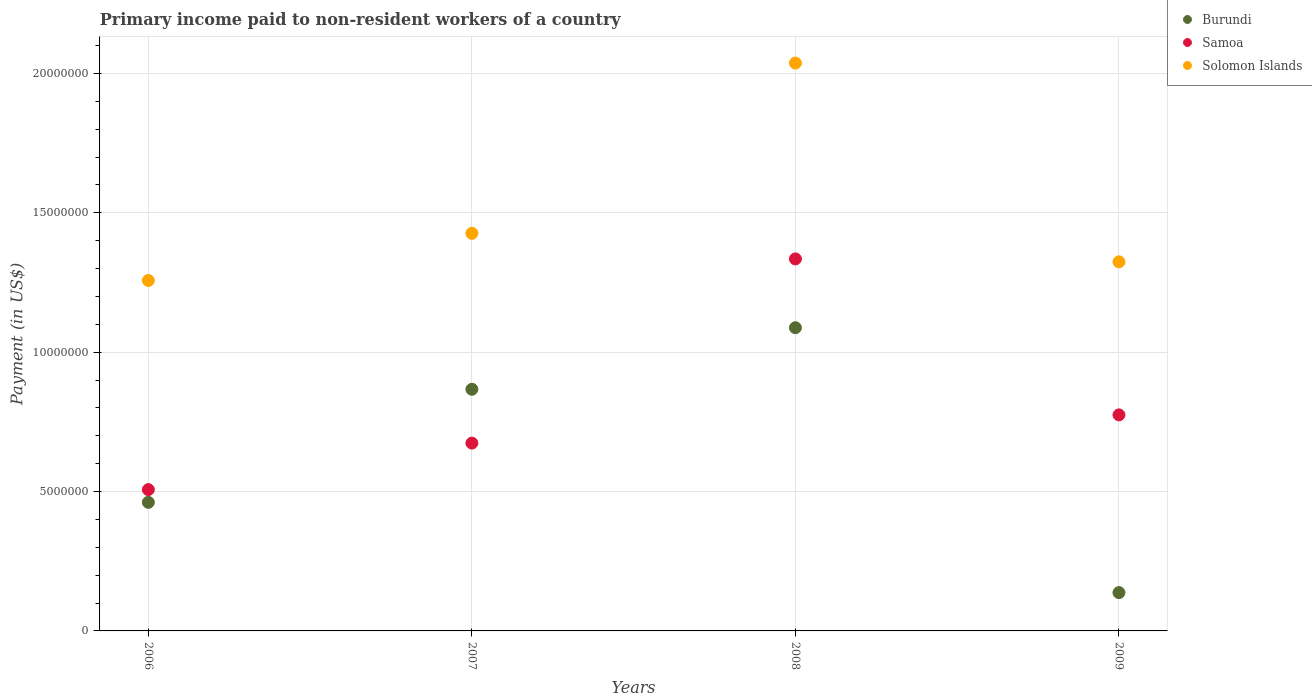How many different coloured dotlines are there?
Give a very brief answer. 3. What is the amount paid to workers in Samoa in 2009?
Make the answer very short. 7.75e+06. Across all years, what is the maximum amount paid to workers in Samoa?
Your answer should be very brief. 1.33e+07. Across all years, what is the minimum amount paid to workers in Solomon Islands?
Your answer should be compact. 1.26e+07. In which year was the amount paid to workers in Solomon Islands minimum?
Keep it short and to the point. 2006. What is the total amount paid to workers in Samoa in the graph?
Make the answer very short. 3.29e+07. What is the difference between the amount paid to workers in Burundi in 2006 and that in 2008?
Give a very brief answer. -6.27e+06. What is the difference between the amount paid to workers in Burundi in 2006 and the amount paid to workers in Samoa in 2007?
Your answer should be compact. -2.13e+06. What is the average amount paid to workers in Burundi per year?
Make the answer very short. 6.38e+06. In the year 2008, what is the difference between the amount paid to workers in Solomon Islands and amount paid to workers in Burundi?
Offer a very short reply. 9.50e+06. In how many years, is the amount paid to workers in Solomon Islands greater than 15000000 US$?
Offer a terse response. 1. What is the ratio of the amount paid to workers in Solomon Islands in 2006 to that in 2007?
Provide a succinct answer. 0.88. Is the difference between the amount paid to workers in Solomon Islands in 2007 and 2009 greater than the difference between the amount paid to workers in Burundi in 2007 and 2009?
Ensure brevity in your answer.  No. What is the difference between the highest and the second highest amount paid to workers in Burundi?
Offer a terse response. 2.21e+06. What is the difference between the highest and the lowest amount paid to workers in Solomon Islands?
Keep it short and to the point. 7.80e+06. In how many years, is the amount paid to workers in Burundi greater than the average amount paid to workers in Burundi taken over all years?
Make the answer very short. 2. Is the amount paid to workers in Samoa strictly greater than the amount paid to workers in Burundi over the years?
Keep it short and to the point. No. Is the amount paid to workers in Burundi strictly less than the amount paid to workers in Samoa over the years?
Provide a short and direct response. No. How many dotlines are there?
Make the answer very short. 3. How many years are there in the graph?
Your answer should be very brief. 4. What is the difference between two consecutive major ticks on the Y-axis?
Offer a terse response. 5.00e+06. Are the values on the major ticks of Y-axis written in scientific E-notation?
Give a very brief answer. No. Does the graph contain any zero values?
Offer a terse response. No. Does the graph contain grids?
Offer a very short reply. Yes. Where does the legend appear in the graph?
Keep it short and to the point. Top right. How many legend labels are there?
Give a very brief answer. 3. What is the title of the graph?
Keep it short and to the point. Primary income paid to non-resident workers of a country. Does "New Zealand" appear as one of the legend labels in the graph?
Offer a terse response. No. What is the label or title of the Y-axis?
Keep it short and to the point. Payment (in US$). What is the Payment (in US$) of Burundi in 2006?
Keep it short and to the point. 4.61e+06. What is the Payment (in US$) of Samoa in 2006?
Your answer should be compact. 5.07e+06. What is the Payment (in US$) in Solomon Islands in 2006?
Your answer should be very brief. 1.26e+07. What is the Payment (in US$) of Burundi in 2007?
Make the answer very short. 8.67e+06. What is the Payment (in US$) of Samoa in 2007?
Your response must be concise. 6.74e+06. What is the Payment (in US$) in Solomon Islands in 2007?
Offer a very short reply. 1.43e+07. What is the Payment (in US$) of Burundi in 2008?
Your response must be concise. 1.09e+07. What is the Payment (in US$) of Samoa in 2008?
Give a very brief answer. 1.33e+07. What is the Payment (in US$) of Solomon Islands in 2008?
Your answer should be compact. 2.04e+07. What is the Payment (in US$) of Burundi in 2009?
Offer a very short reply. 1.38e+06. What is the Payment (in US$) in Samoa in 2009?
Provide a short and direct response. 7.75e+06. What is the Payment (in US$) of Solomon Islands in 2009?
Provide a succinct answer. 1.32e+07. Across all years, what is the maximum Payment (in US$) in Burundi?
Offer a terse response. 1.09e+07. Across all years, what is the maximum Payment (in US$) in Samoa?
Provide a succinct answer. 1.33e+07. Across all years, what is the maximum Payment (in US$) of Solomon Islands?
Ensure brevity in your answer.  2.04e+07. Across all years, what is the minimum Payment (in US$) of Burundi?
Offer a very short reply. 1.38e+06. Across all years, what is the minimum Payment (in US$) of Samoa?
Provide a short and direct response. 5.07e+06. Across all years, what is the minimum Payment (in US$) of Solomon Islands?
Provide a short and direct response. 1.26e+07. What is the total Payment (in US$) in Burundi in the graph?
Offer a very short reply. 2.55e+07. What is the total Payment (in US$) of Samoa in the graph?
Your answer should be very brief. 3.29e+07. What is the total Payment (in US$) in Solomon Islands in the graph?
Offer a terse response. 6.05e+07. What is the difference between the Payment (in US$) in Burundi in 2006 and that in 2007?
Provide a short and direct response. -4.06e+06. What is the difference between the Payment (in US$) in Samoa in 2006 and that in 2007?
Give a very brief answer. -1.67e+06. What is the difference between the Payment (in US$) in Solomon Islands in 2006 and that in 2007?
Provide a short and direct response. -1.69e+06. What is the difference between the Payment (in US$) of Burundi in 2006 and that in 2008?
Provide a short and direct response. -6.27e+06. What is the difference between the Payment (in US$) of Samoa in 2006 and that in 2008?
Provide a short and direct response. -8.28e+06. What is the difference between the Payment (in US$) of Solomon Islands in 2006 and that in 2008?
Give a very brief answer. -7.80e+06. What is the difference between the Payment (in US$) in Burundi in 2006 and that in 2009?
Give a very brief answer. 3.24e+06. What is the difference between the Payment (in US$) of Samoa in 2006 and that in 2009?
Offer a terse response. -2.68e+06. What is the difference between the Payment (in US$) of Solomon Islands in 2006 and that in 2009?
Your response must be concise. -6.69e+05. What is the difference between the Payment (in US$) of Burundi in 2007 and that in 2008?
Make the answer very short. -2.21e+06. What is the difference between the Payment (in US$) of Samoa in 2007 and that in 2008?
Ensure brevity in your answer.  -6.61e+06. What is the difference between the Payment (in US$) in Solomon Islands in 2007 and that in 2008?
Offer a terse response. -6.11e+06. What is the difference between the Payment (in US$) in Burundi in 2007 and that in 2009?
Keep it short and to the point. 7.29e+06. What is the difference between the Payment (in US$) of Samoa in 2007 and that in 2009?
Your answer should be very brief. -1.01e+06. What is the difference between the Payment (in US$) in Solomon Islands in 2007 and that in 2009?
Your answer should be very brief. 1.02e+06. What is the difference between the Payment (in US$) of Burundi in 2008 and that in 2009?
Provide a succinct answer. 9.50e+06. What is the difference between the Payment (in US$) of Samoa in 2008 and that in 2009?
Offer a terse response. 5.60e+06. What is the difference between the Payment (in US$) in Solomon Islands in 2008 and that in 2009?
Your response must be concise. 7.13e+06. What is the difference between the Payment (in US$) in Burundi in 2006 and the Payment (in US$) in Samoa in 2007?
Offer a very short reply. -2.13e+06. What is the difference between the Payment (in US$) of Burundi in 2006 and the Payment (in US$) of Solomon Islands in 2007?
Ensure brevity in your answer.  -9.65e+06. What is the difference between the Payment (in US$) of Samoa in 2006 and the Payment (in US$) of Solomon Islands in 2007?
Provide a short and direct response. -9.20e+06. What is the difference between the Payment (in US$) of Burundi in 2006 and the Payment (in US$) of Samoa in 2008?
Your answer should be compact. -8.73e+06. What is the difference between the Payment (in US$) in Burundi in 2006 and the Payment (in US$) in Solomon Islands in 2008?
Your answer should be compact. -1.58e+07. What is the difference between the Payment (in US$) in Samoa in 2006 and the Payment (in US$) in Solomon Islands in 2008?
Offer a very short reply. -1.53e+07. What is the difference between the Payment (in US$) of Burundi in 2006 and the Payment (in US$) of Samoa in 2009?
Your answer should be very brief. -3.14e+06. What is the difference between the Payment (in US$) of Burundi in 2006 and the Payment (in US$) of Solomon Islands in 2009?
Ensure brevity in your answer.  -8.63e+06. What is the difference between the Payment (in US$) in Samoa in 2006 and the Payment (in US$) in Solomon Islands in 2009?
Give a very brief answer. -8.17e+06. What is the difference between the Payment (in US$) in Burundi in 2007 and the Payment (in US$) in Samoa in 2008?
Ensure brevity in your answer.  -4.68e+06. What is the difference between the Payment (in US$) in Burundi in 2007 and the Payment (in US$) in Solomon Islands in 2008?
Keep it short and to the point. -1.17e+07. What is the difference between the Payment (in US$) in Samoa in 2007 and the Payment (in US$) in Solomon Islands in 2008?
Provide a short and direct response. -1.36e+07. What is the difference between the Payment (in US$) of Burundi in 2007 and the Payment (in US$) of Samoa in 2009?
Your answer should be compact. 9.19e+05. What is the difference between the Payment (in US$) in Burundi in 2007 and the Payment (in US$) in Solomon Islands in 2009?
Ensure brevity in your answer.  -4.57e+06. What is the difference between the Payment (in US$) in Samoa in 2007 and the Payment (in US$) in Solomon Islands in 2009?
Provide a succinct answer. -6.50e+06. What is the difference between the Payment (in US$) of Burundi in 2008 and the Payment (in US$) of Samoa in 2009?
Give a very brief answer. 3.13e+06. What is the difference between the Payment (in US$) in Burundi in 2008 and the Payment (in US$) in Solomon Islands in 2009?
Your answer should be compact. -2.36e+06. What is the difference between the Payment (in US$) of Samoa in 2008 and the Payment (in US$) of Solomon Islands in 2009?
Ensure brevity in your answer.  1.06e+05. What is the average Payment (in US$) of Burundi per year?
Give a very brief answer. 6.38e+06. What is the average Payment (in US$) of Samoa per year?
Make the answer very short. 8.23e+06. What is the average Payment (in US$) in Solomon Islands per year?
Offer a very short reply. 1.51e+07. In the year 2006, what is the difference between the Payment (in US$) of Burundi and Payment (in US$) of Samoa?
Make the answer very short. -4.57e+05. In the year 2006, what is the difference between the Payment (in US$) in Burundi and Payment (in US$) in Solomon Islands?
Offer a terse response. -7.96e+06. In the year 2006, what is the difference between the Payment (in US$) in Samoa and Payment (in US$) in Solomon Islands?
Ensure brevity in your answer.  -7.50e+06. In the year 2007, what is the difference between the Payment (in US$) in Burundi and Payment (in US$) in Samoa?
Offer a very short reply. 1.93e+06. In the year 2007, what is the difference between the Payment (in US$) in Burundi and Payment (in US$) in Solomon Islands?
Make the answer very short. -5.60e+06. In the year 2007, what is the difference between the Payment (in US$) of Samoa and Payment (in US$) of Solomon Islands?
Offer a terse response. -7.53e+06. In the year 2008, what is the difference between the Payment (in US$) of Burundi and Payment (in US$) of Samoa?
Offer a very short reply. -2.47e+06. In the year 2008, what is the difference between the Payment (in US$) of Burundi and Payment (in US$) of Solomon Islands?
Give a very brief answer. -9.50e+06. In the year 2008, what is the difference between the Payment (in US$) of Samoa and Payment (in US$) of Solomon Islands?
Provide a succinct answer. -7.03e+06. In the year 2009, what is the difference between the Payment (in US$) in Burundi and Payment (in US$) in Samoa?
Offer a very short reply. -6.38e+06. In the year 2009, what is the difference between the Payment (in US$) of Burundi and Payment (in US$) of Solomon Islands?
Make the answer very short. -1.19e+07. In the year 2009, what is the difference between the Payment (in US$) of Samoa and Payment (in US$) of Solomon Islands?
Keep it short and to the point. -5.49e+06. What is the ratio of the Payment (in US$) in Burundi in 2006 to that in 2007?
Provide a succinct answer. 0.53. What is the ratio of the Payment (in US$) in Samoa in 2006 to that in 2007?
Keep it short and to the point. 0.75. What is the ratio of the Payment (in US$) in Solomon Islands in 2006 to that in 2007?
Offer a very short reply. 0.88. What is the ratio of the Payment (in US$) in Burundi in 2006 to that in 2008?
Offer a terse response. 0.42. What is the ratio of the Payment (in US$) in Samoa in 2006 to that in 2008?
Offer a very short reply. 0.38. What is the ratio of the Payment (in US$) of Solomon Islands in 2006 to that in 2008?
Offer a terse response. 0.62. What is the ratio of the Payment (in US$) in Burundi in 2006 to that in 2009?
Offer a very short reply. 3.35. What is the ratio of the Payment (in US$) in Samoa in 2006 to that in 2009?
Provide a succinct answer. 0.65. What is the ratio of the Payment (in US$) in Solomon Islands in 2006 to that in 2009?
Provide a succinct answer. 0.95. What is the ratio of the Payment (in US$) in Burundi in 2007 to that in 2008?
Keep it short and to the point. 0.8. What is the ratio of the Payment (in US$) of Samoa in 2007 to that in 2008?
Make the answer very short. 0.5. What is the ratio of the Payment (in US$) in Solomon Islands in 2007 to that in 2008?
Keep it short and to the point. 0.7. What is the ratio of the Payment (in US$) in Burundi in 2007 to that in 2009?
Keep it short and to the point. 6.3. What is the ratio of the Payment (in US$) of Samoa in 2007 to that in 2009?
Your answer should be very brief. 0.87. What is the ratio of the Payment (in US$) in Solomon Islands in 2007 to that in 2009?
Provide a succinct answer. 1.08. What is the ratio of the Payment (in US$) in Burundi in 2008 to that in 2009?
Offer a terse response. 7.91. What is the ratio of the Payment (in US$) in Samoa in 2008 to that in 2009?
Keep it short and to the point. 1.72. What is the ratio of the Payment (in US$) in Solomon Islands in 2008 to that in 2009?
Offer a very short reply. 1.54. What is the difference between the highest and the second highest Payment (in US$) of Burundi?
Your answer should be very brief. 2.21e+06. What is the difference between the highest and the second highest Payment (in US$) of Samoa?
Your answer should be very brief. 5.60e+06. What is the difference between the highest and the second highest Payment (in US$) of Solomon Islands?
Give a very brief answer. 6.11e+06. What is the difference between the highest and the lowest Payment (in US$) of Burundi?
Offer a very short reply. 9.50e+06. What is the difference between the highest and the lowest Payment (in US$) in Samoa?
Keep it short and to the point. 8.28e+06. What is the difference between the highest and the lowest Payment (in US$) of Solomon Islands?
Offer a very short reply. 7.80e+06. 